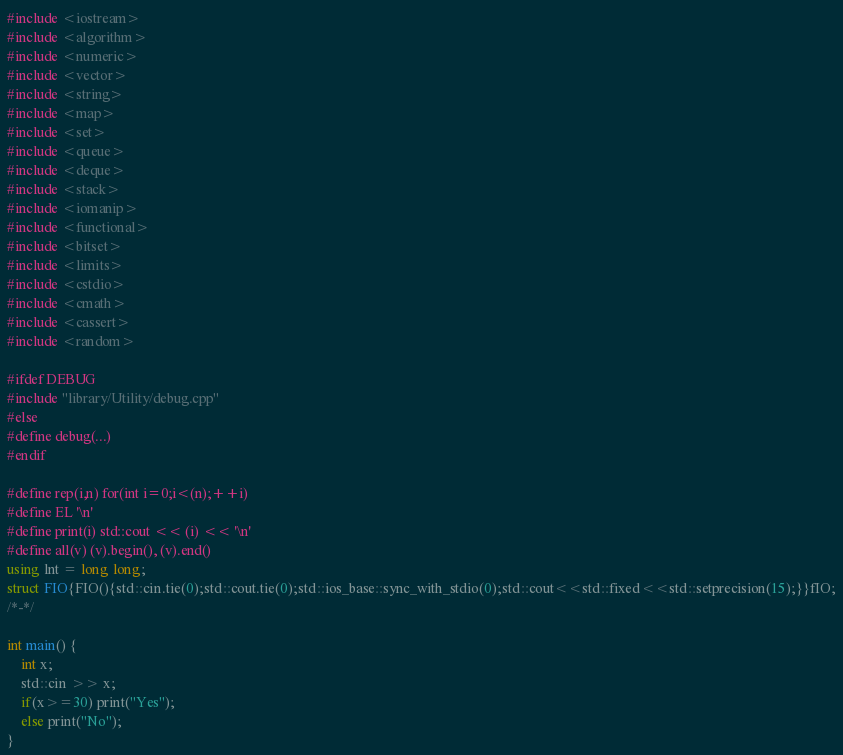<code> <loc_0><loc_0><loc_500><loc_500><_C++_>#include <iostream>
#include <algorithm>
#include <numeric>
#include <vector>
#include <string>
#include <map>
#include <set>
#include <queue>
#include <deque>
#include <stack>
#include <iomanip>
#include <functional>
#include <bitset>
#include <limits>
#include <cstdio>
#include <cmath>
#include <cassert>
#include <random>

#ifdef DEBUG
#include "library/Utility/debug.cpp"
#else
#define debug(...)
#endif

#define rep(i,n) for(int i=0;i<(n);++i)
#define EL '\n'
#define print(i) std::cout << (i) << '\n'
#define all(v) (v).begin(), (v).end()
using lnt = long long;
struct FIO{FIO(){std::cin.tie(0);std::cout.tie(0);std::ios_base::sync_with_stdio(0);std::cout<<std::fixed<<std::setprecision(15);}}fIO;
/*-*/

int main() {
	int x;
	std::cin >> x;
	if(x>=30) print("Yes");
	else print("No");
}
</code> 